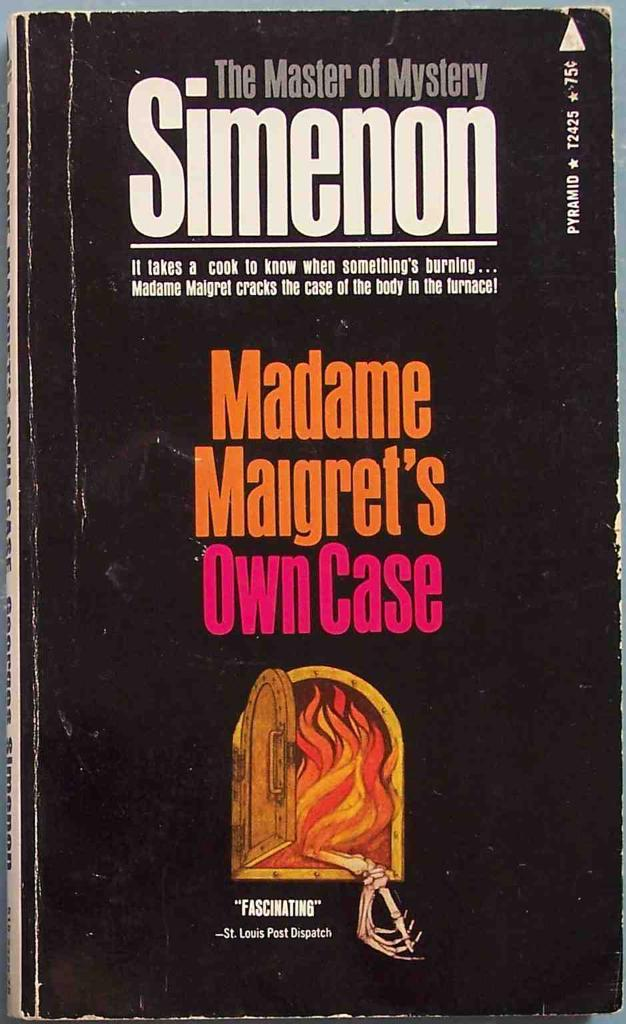<image>
Render a clear and concise summary of the photo. A vintage copy of Madame Maigret's Own Case 